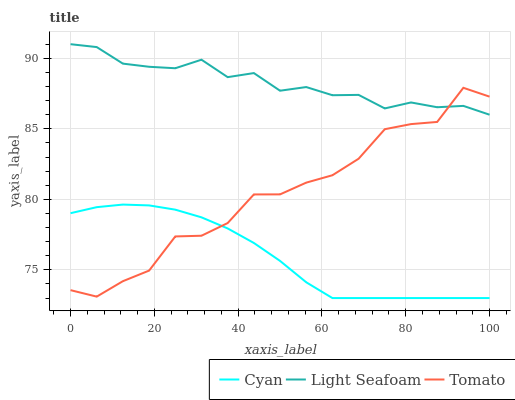Does Cyan have the minimum area under the curve?
Answer yes or no. Yes. Does Light Seafoam have the maximum area under the curve?
Answer yes or no. Yes. Does Light Seafoam have the minimum area under the curve?
Answer yes or no. No. Does Cyan have the maximum area under the curve?
Answer yes or no. No. Is Cyan the smoothest?
Answer yes or no. Yes. Is Tomato the roughest?
Answer yes or no. Yes. Is Light Seafoam the smoothest?
Answer yes or no. No. Is Light Seafoam the roughest?
Answer yes or no. No. Does Cyan have the lowest value?
Answer yes or no. Yes. Does Light Seafoam have the lowest value?
Answer yes or no. No. Does Light Seafoam have the highest value?
Answer yes or no. Yes. Does Cyan have the highest value?
Answer yes or no. No. Is Cyan less than Light Seafoam?
Answer yes or no. Yes. Is Light Seafoam greater than Cyan?
Answer yes or no. Yes. Does Cyan intersect Tomato?
Answer yes or no. Yes. Is Cyan less than Tomato?
Answer yes or no. No. Is Cyan greater than Tomato?
Answer yes or no. No. Does Cyan intersect Light Seafoam?
Answer yes or no. No. 